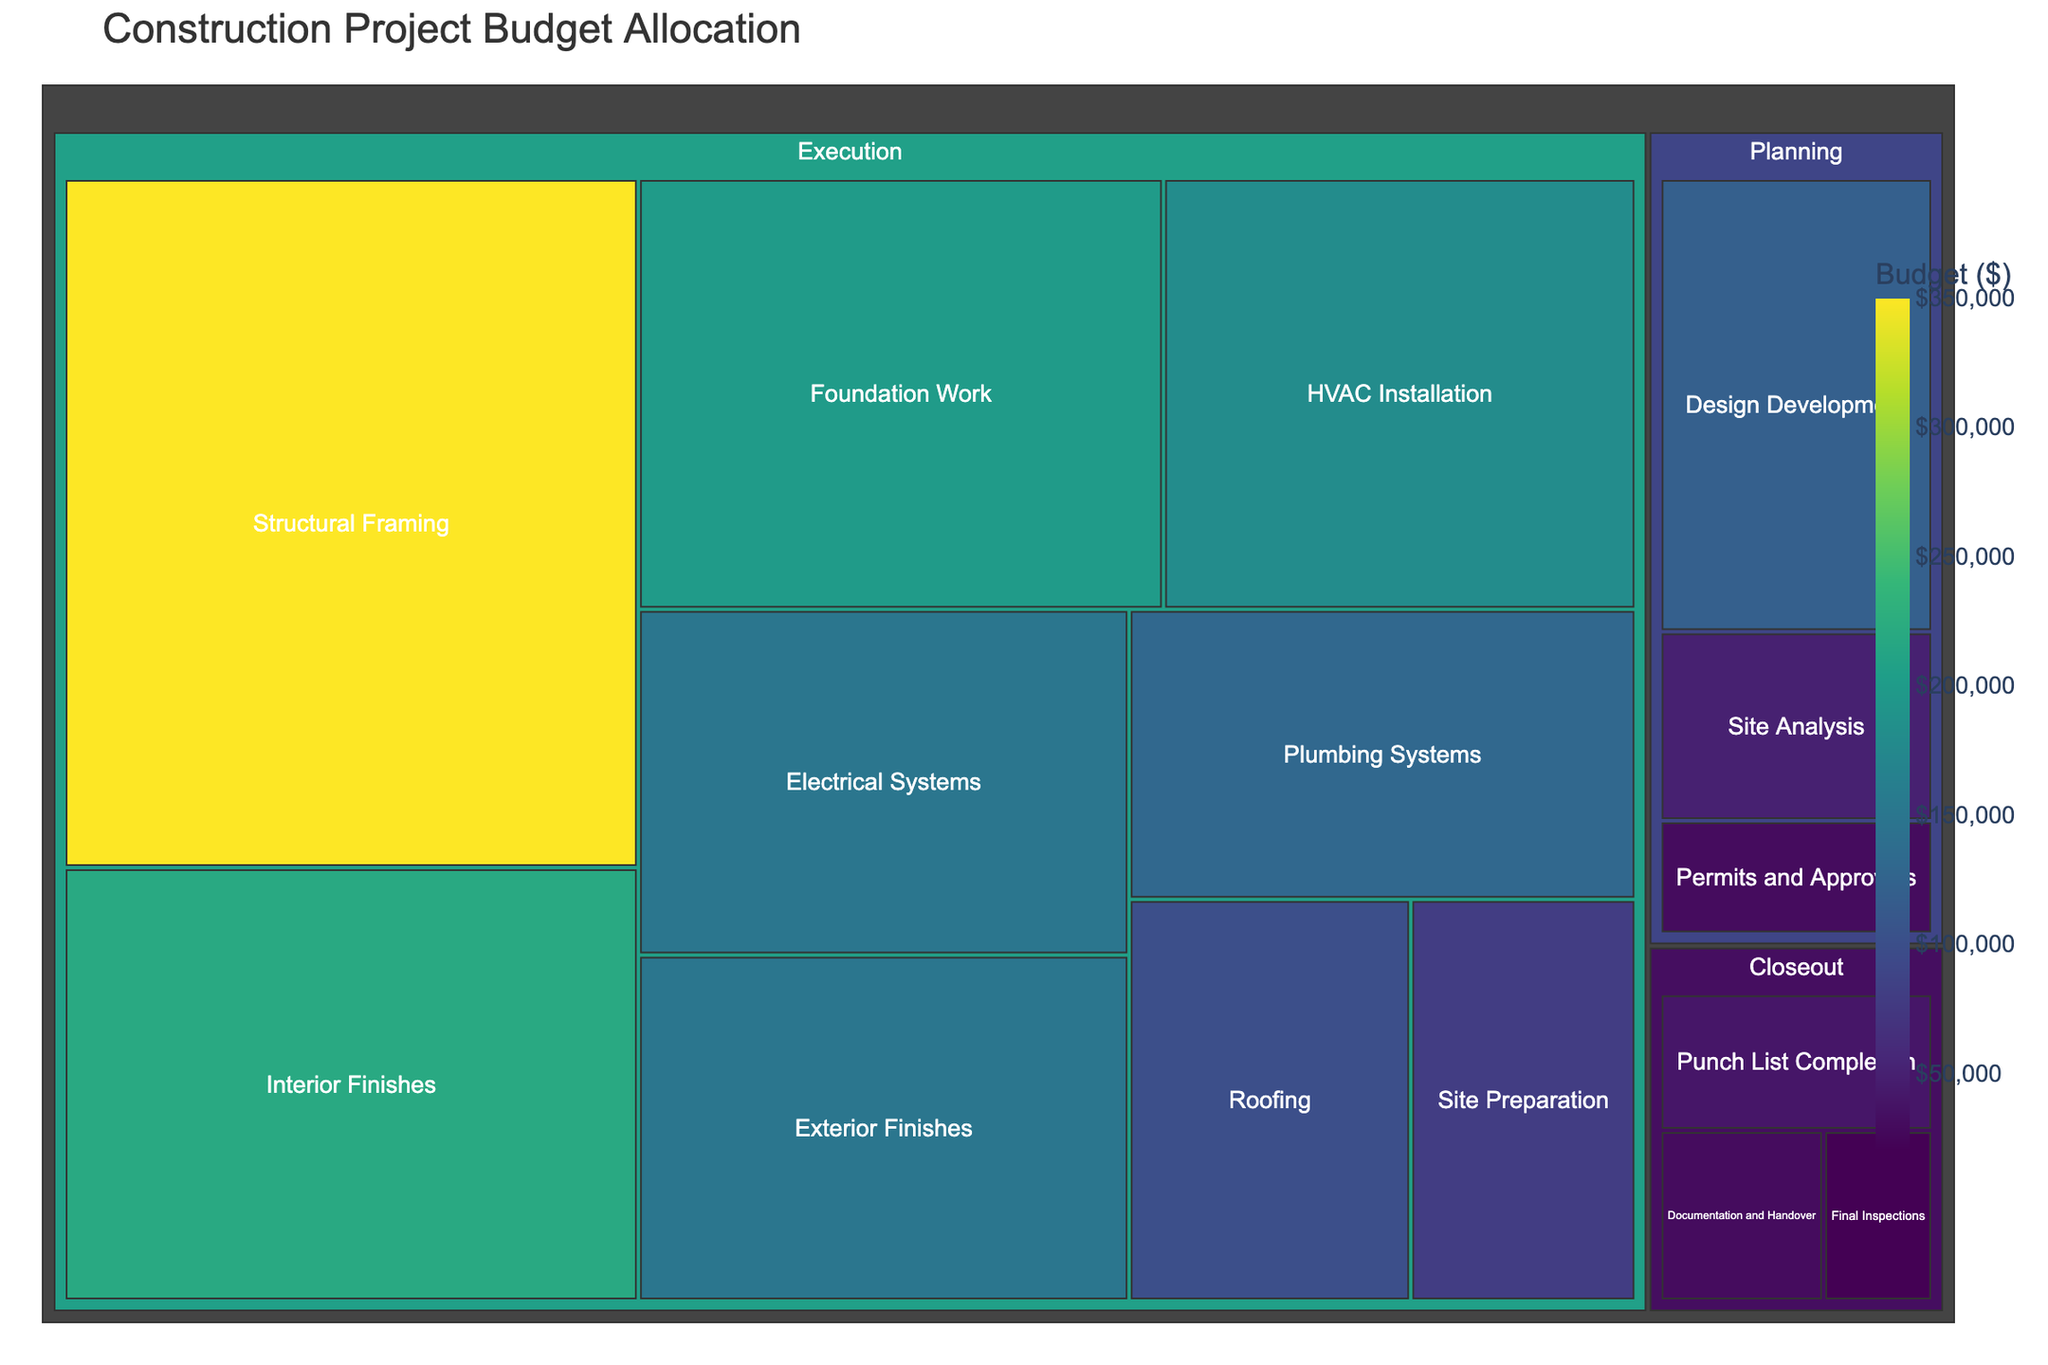What's the title of the figure? The title is located at the top of the figure.
Answer: Construction Project Budget Allocation How many phases are displayed in the treemap? There are distinct sections in the treemap labeled for each phase of the construction project. Count the unique labels.
Answer: 3 What is the total budget allocated to the Planning phase? Identify and sum the budget values of all tasks under the Planning phase. The relevant tasks are Site Analysis, Design Development, and Permits and Approvals. So, the total budget is 50,000 + 120,000 + 30,000 = 200,000.
Answer: 200,000 Which task within the Execution phase has the highest budget? Locate the Execution phase in the treemap and compare the budgets of each task listed under it. The highest value is 350,000.
Answer: Structural Framing How does the budget for Roofing compare to the budget for Plumbing Systems in the Execution phase? Find the budget amounts for Roofing and Plumbing Systems within the Execution phase and compare them: 100,000 vs. 130,000.
Answer: Roofing has a lower budget than Plumbing Systems What is the total budget allocated to the Execution phase? Sum the budget values of all tasks under the Execution phase. The relevant budgets are 80,000, 200,000, 350,000, 150,000, 130,000, 180,000, 100,000, 220,000, and 150,000. The total is 1,560,000.
Answer: 1,560,000 What percentage of the Execution phase's budget is allocated to HVAC Installation? Divide the budget for HVAC Installation by the total budget for the Execution phase and multiply by 100. Calculate as (180,000 / 1,560,000) * 100.
Answer: Approximately 11.54% What is the combined budget for all tasks under the Closeout phase? Sum the budget values of all tasks under the Closeout phase. The relevant budgets are 20,000, 40,000, and 30,000. The total is 90,000.
Answer: 90,000 Which phase has the smallest total budget allocation? Compare the total budgets of all phases. Summarize: Planning (200,000), Execution (1,560,000), Closeout (90,000).
Answer: Closeout What is the difference in budget between Interior Finishes and Exterior Finishes in the Execution phase? Find the budget values for Interior Finishes and Exterior Finishes within the Execution phase and compute the difference: 220,000 - 150,000.
Answer: 70,000 